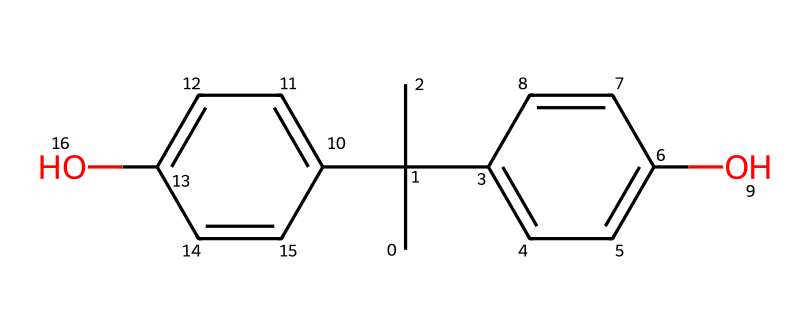What is the molecular formula of bisphenol A? To determine the molecular formula from the SMILES representation, we can count the different types of atoms. The structure shows there are 15 carbon atoms, 16 hydrogen atoms, and 2 oxygen atoms. Thus, the molecular formula is C15H16O2.
Answer: C15H16O2 How many hydroxyl groups are present in bisphenol A? By analyzing the SMILES representation, we can find the -OH (hydroxyl) groups. They are indicated by the 'O' connected to carbon atoms, and there are two such -OH groups in the structure.
Answer: 2 Is bisphenol A a type of phenolic compound? Bisphenol A contains two phenolic rings (as seen by the alternating double bonds and -OH groups on aromatic rings) in its structure, which classifies it as a phenolic compound.
Answer: Yes What is the total number of aromatic rings in bisphenol A? By examining the chemical structure, we can identify two distinct aromatic rings (the benzene-like structures) due to the presence of alternating double bonds.
Answer: 2 Which characteristic of bisphenol A raises concerns regarding its safety? The presence of hydroxyl groups and the ability to mimic estrogen in biological systems lead to concerns about bisphenol A acting as an endocrine disruptor, which poses safety risks.
Answer: Endocrine disruptor Does bisphenol A contain any alkyl groups? Looking at the SMILES representation, the branching carbon structure resembles an alkyl group (specifically the tert-butyl group), which is present in bisphenol A.
Answer: Yes 